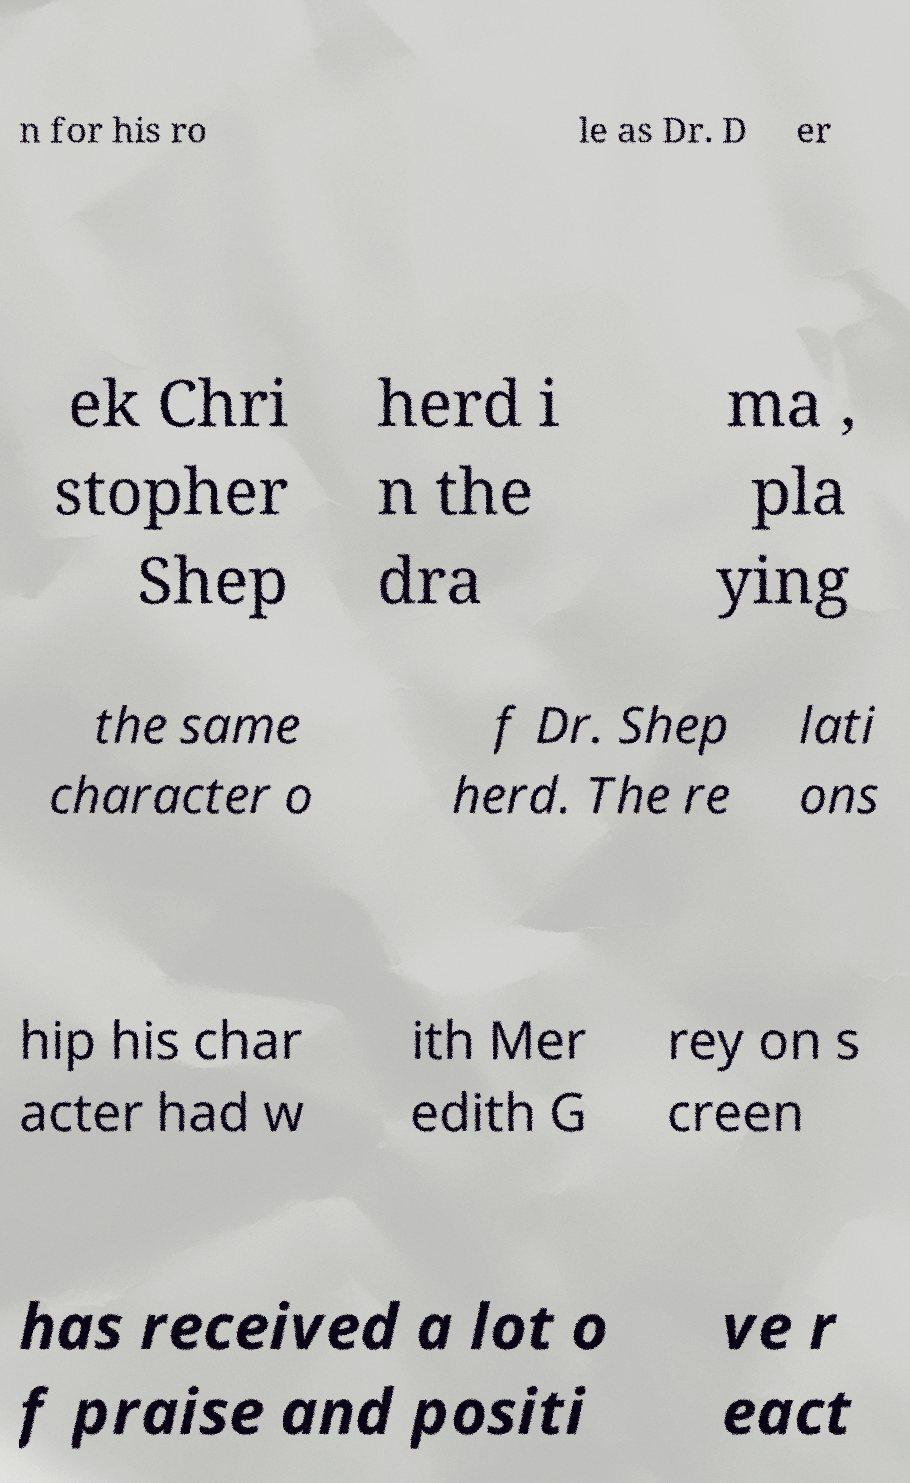There's text embedded in this image that I need extracted. Can you transcribe it verbatim? n for his ro le as Dr. D er ek Chri stopher Shep herd i n the dra ma , pla ying the same character o f Dr. Shep herd. The re lati ons hip his char acter had w ith Mer edith G rey on s creen has received a lot o f praise and positi ve r eact 